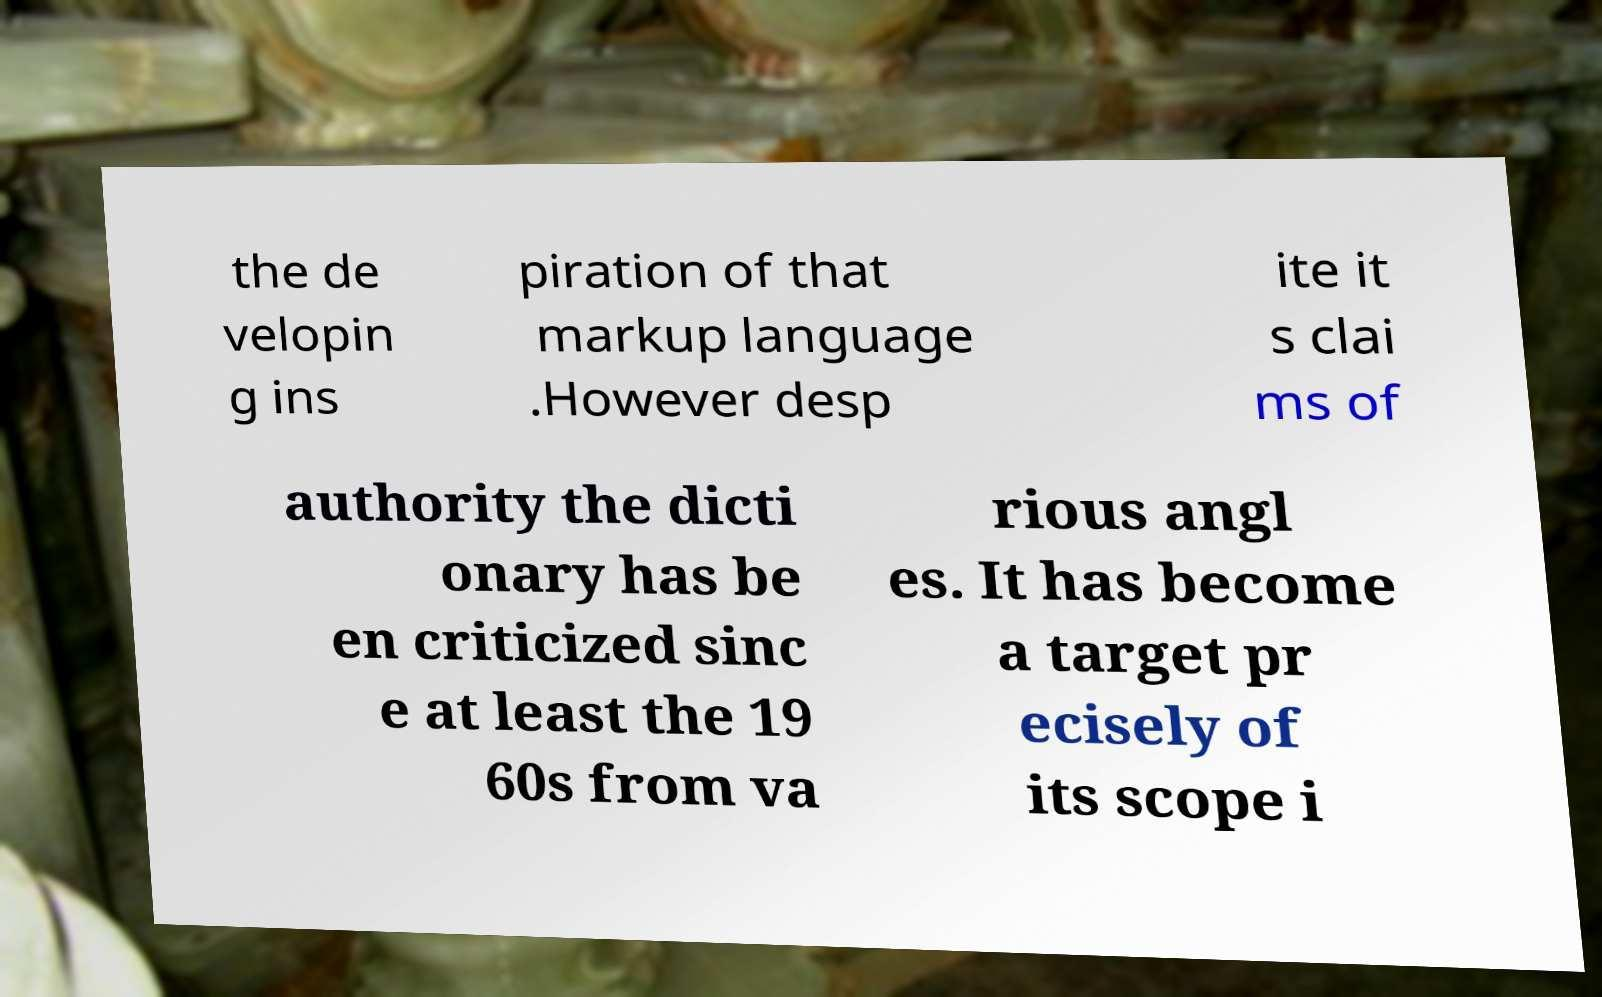Please read and relay the text visible in this image. What does it say? the de velopin g ins piration of that markup language .However desp ite it s clai ms of authority the dicti onary has be en criticized sinc e at least the 19 60s from va rious angl es. It has become a target pr ecisely of its scope i 